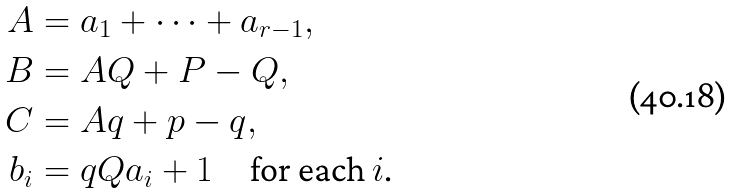Convert formula to latex. <formula><loc_0><loc_0><loc_500><loc_500>A & = a _ { 1 } + \dots + a _ { r - 1 } , \\ B & = A Q + P - Q , \\ C & = A q + p - q , \\ b _ { i } & = q Q a _ { i } + 1 \quad \text {for each $i$.}</formula> 